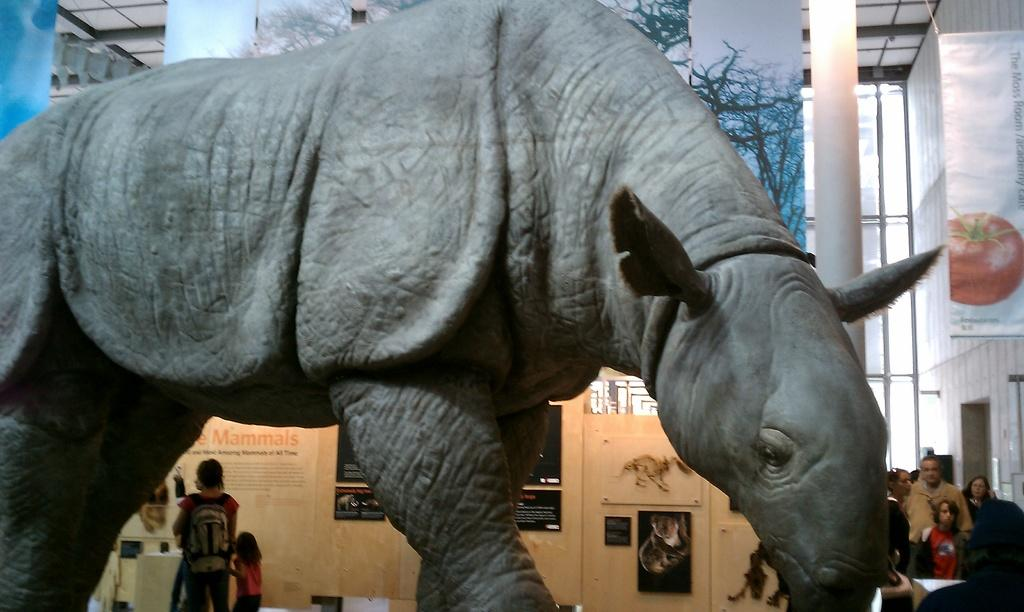What type of animal is present in the image? There is an animal in the image, but its specific type is not mentioned in the facts. What can be seen on the wooden surface in the image? There are people's posts on a wooden surface in the image. What architectural elements are visible in the image? There are pillars in the image. What type of signage is present in the image? There are banners in the image. What material is visible in the image? There is glass visible in the image. What type of bird can be seen flying over the railway in the image? There is no railway or bird present in the image. What type of order is being followed by the people in the image? There is no indication of any specific order being followed by the people in the image. 